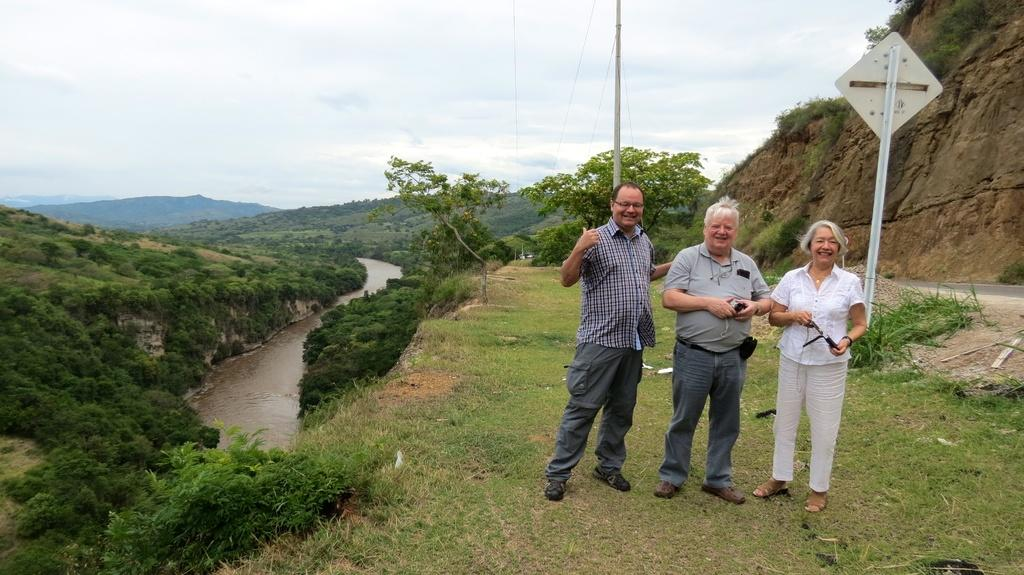What is one of the natural elements present in the image? There is water in the image. What type of vegetation can be seen in the image? There are trees, plants, and grass in the image. What geographical feature is visible in the image? There are hills in the image. What man-made object is present in the image? There is a sign board in the image. How many people are visible in the image? There are three people standing in the front of the image. What is visible at the top of the image? The sky is visible at the top of the image. What type of wire is being used by the people in the image? There is no wire present in the image; the people are standing without any visible wires. What color is the sheet covering the hills in the image? There is no sheet covering the hills in the image; the hills are visible without any covering. 